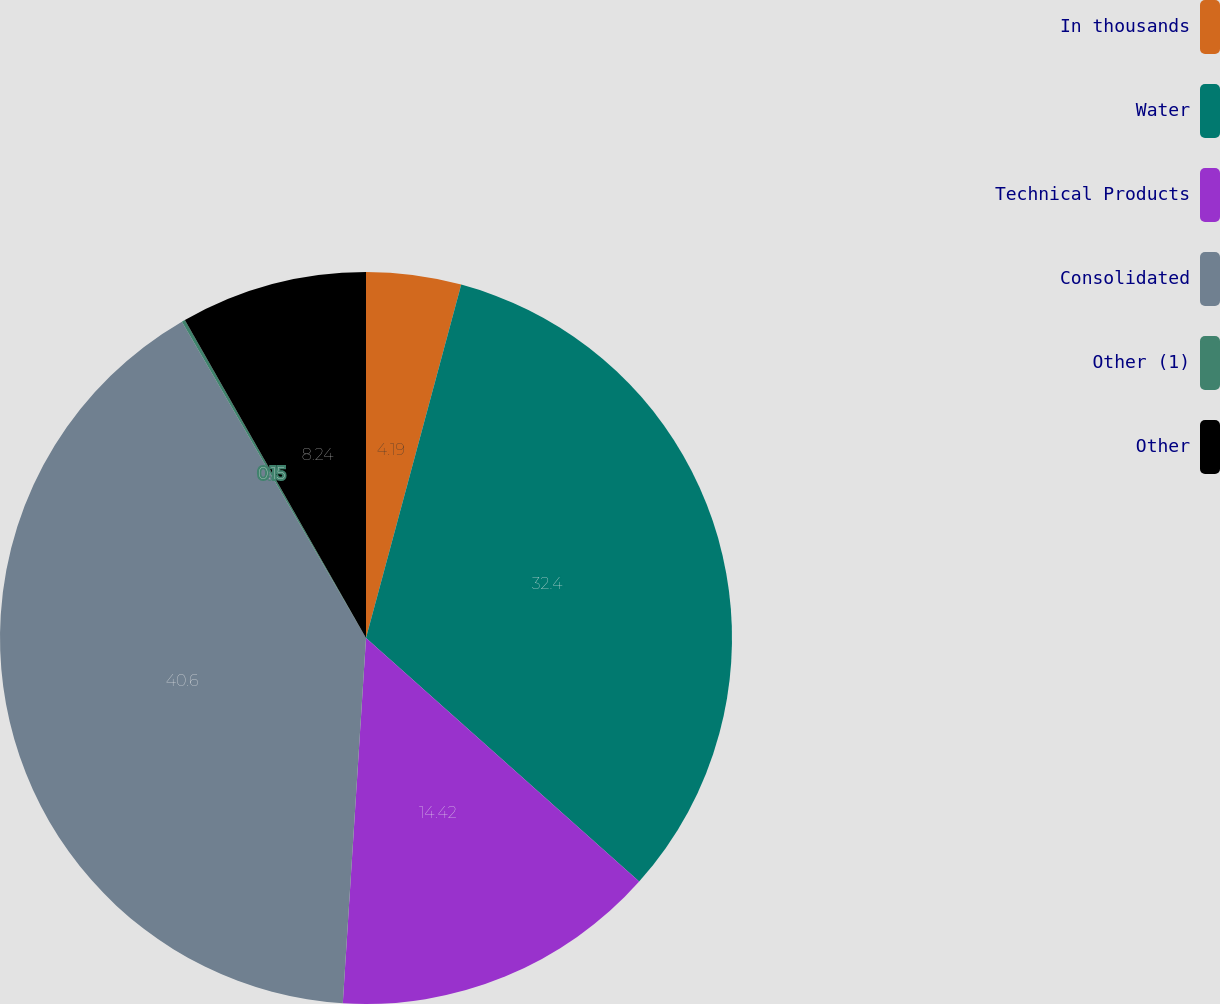Convert chart. <chart><loc_0><loc_0><loc_500><loc_500><pie_chart><fcel>In thousands<fcel>Water<fcel>Technical Products<fcel>Consolidated<fcel>Other (1)<fcel>Other<nl><fcel>4.19%<fcel>32.4%<fcel>14.42%<fcel>40.6%<fcel>0.15%<fcel>8.24%<nl></chart> 